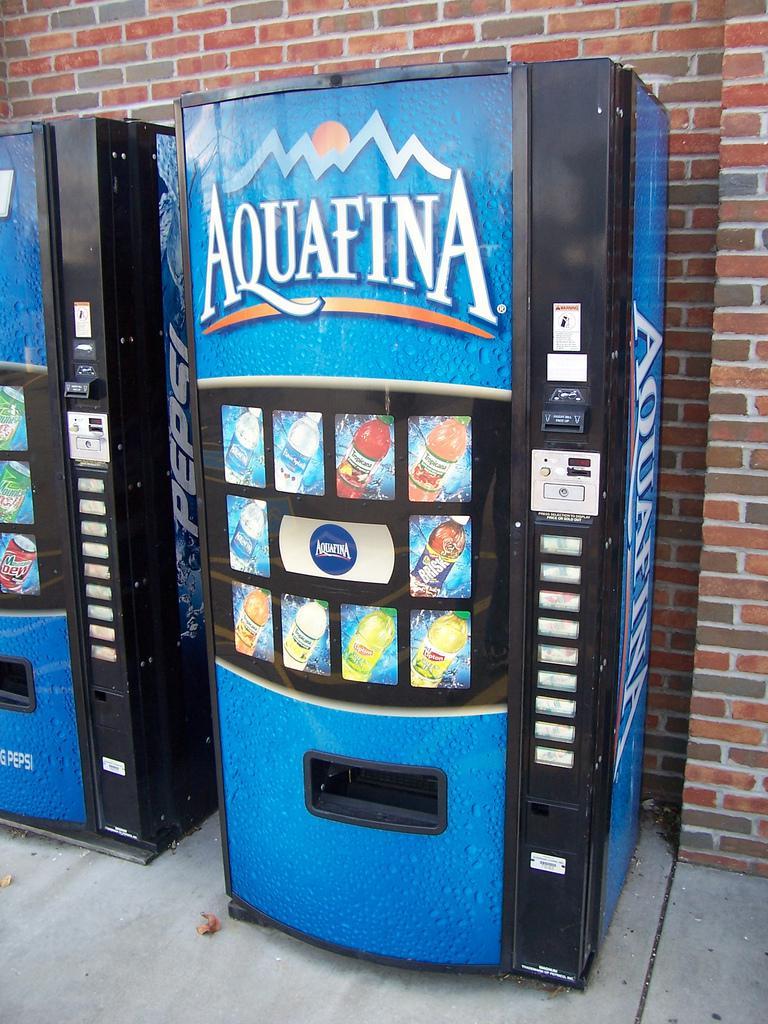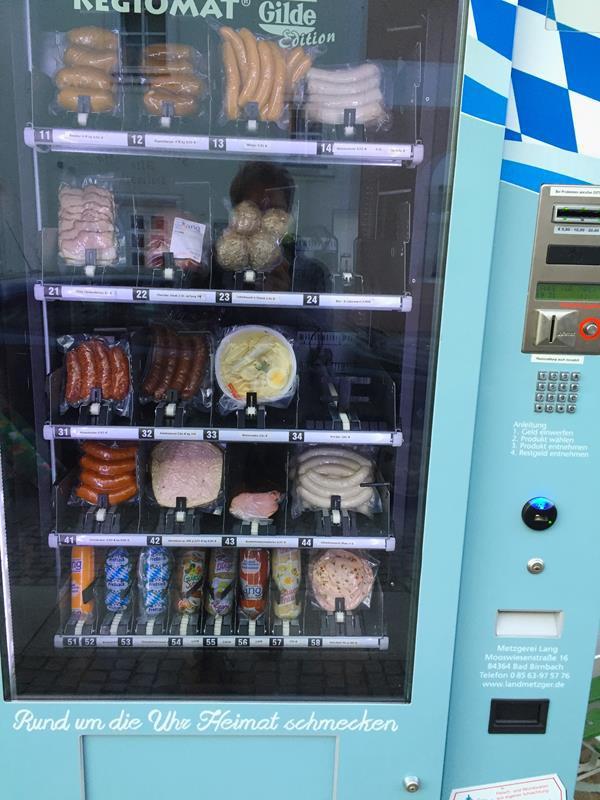The first image is the image on the left, the second image is the image on the right. Evaluate the accuracy of this statement regarding the images: "Each image shows predominantly one vending machine, and all vending machines shown are blue.". Is it true? Answer yes or no. Yes. The first image is the image on the left, the second image is the image on the right. Examine the images to the left and right. Is the description "Each image prominently features exactly one vending machine, which is blue." accurate? Answer yes or no. Yes. The first image is the image on the left, the second image is the image on the right. For the images shown, is this caption "There are more machines in the image on the right than in the image on the left." true? Answer yes or no. No. The first image is the image on the left, the second image is the image on the right. For the images displayed, is the sentence "In one of the images, a pepsi machine stands alone." factually correct? Answer yes or no. No. 